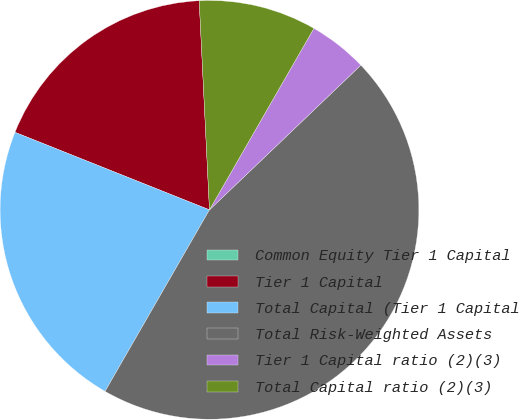<chart> <loc_0><loc_0><loc_500><loc_500><pie_chart><fcel>Common Equity Tier 1 Capital<fcel>Tier 1 Capital<fcel>Total Capital (Tier 1 Capital<fcel>Total Risk-Weighted Assets<fcel>Tier 1 Capital ratio (2)(3)<fcel>Total Capital ratio (2)(3)<nl><fcel>0.0%<fcel>18.18%<fcel>22.73%<fcel>45.45%<fcel>4.55%<fcel>9.09%<nl></chart> 